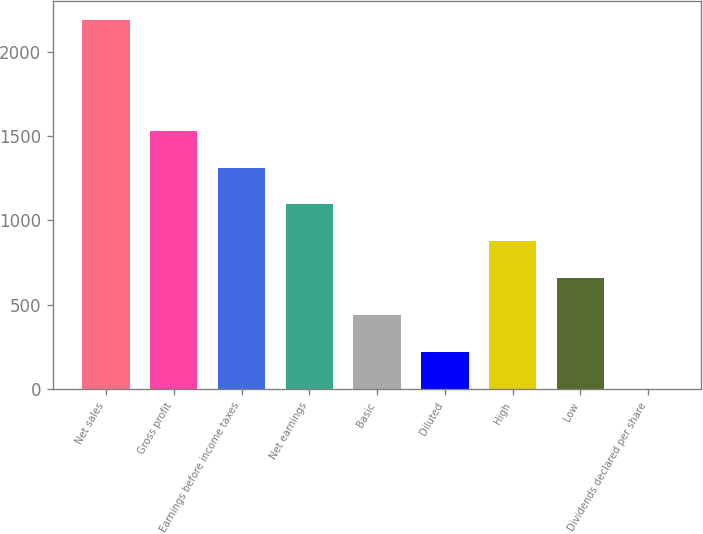<chart> <loc_0><loc_0><loc_500><loc_500><bar_chart><fcel>Net sales<fcel>Gross profit<fcel>Earnings before income taxes<fcel>Net earnings<fcel>Basic<fcel>Diluted<fcel>High<fcel>Low<fcel>Dividends declared per share<nl><fcel>2190<fcel>1533.06<fcel>1314.09<fcel>1095.12<fcel>438.21<fcel>219.24<fcel>876.15<fcel>657.18<fcel>0.27<nl></chart> 